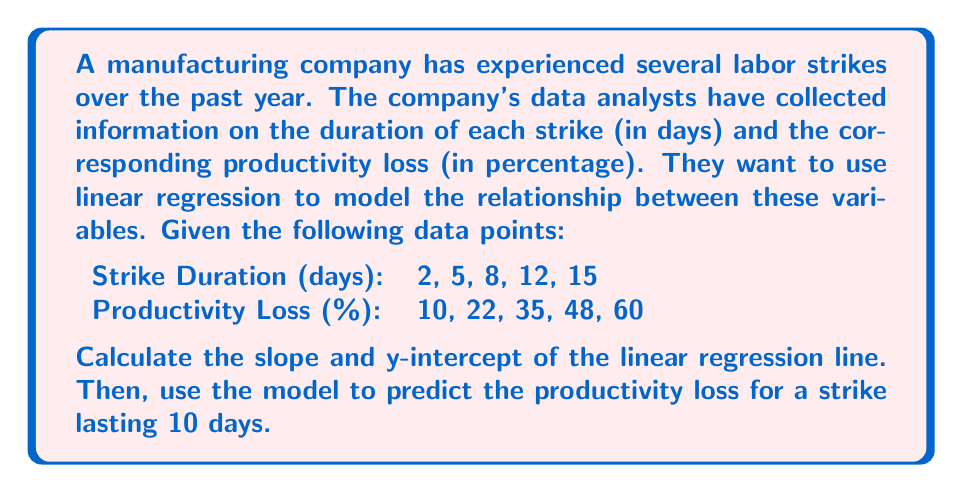Give your solution to this math problem. To solve this problem, we'll use the linear regression equation:
$$ y = mx + b $$
where $m$ is the slope and $b$ is the y-intercept.

Step 1: Calculate the means of x (strike duration) and y (productivity loss):
$$ \bar{x} = \frac{2 + 5 + 8 + 12 + 15}{5} = 8.4 $$
$$ \bar{y} = \frac{10 + 22 + 35 + 48 + 60}{5} = 35 $$

Step 2: Calculate the slope (m) using the formula:
$$ m = \frac{\sum(x_i - \bar{x})(y_i - \bar{y})}{\sum(x_i - \bar{x})^2} $$

$$ m = \frac{(-6.4)(-25) + (-3.4)(-13) + (-0.4)(0) + (3.6)(13) + (6.6)(25)}{(-6.4)^2 + (-3.4)^2 + (-0.4)^2 + (3.6)^2 + (6.6)^2} $$

$$ m = \frac{160 + 44.2 + 0 + 46.8 + 165}{40.96 + 11.56 + 0.16 + 12.96 + 43.56} = \frac{416}{109.2} = 3.81 $$

Step 3: Calculate the y-intercept (b) using the formula:
$$ b = \bar{y} - m\bar{x} $$
$$ b = 35 - 3.81(8.4) = 35 - 32 = 3 $$

Step 4: Write the linear regression equation:
$$ y = 3.81x + 3 $$

Step 5: Predict the productivity loss for a 10-day strike:
$$ y = 3.81(10) + 3 = 38.1 + 3 = 41.1 $$

Therefore, the predicted productivity loss for a 10-day strike is 41.1%.
Answer: Slope: 3.81, y-intercept: 3, Predicted productivity loss for 10-day strike: 41.1% 